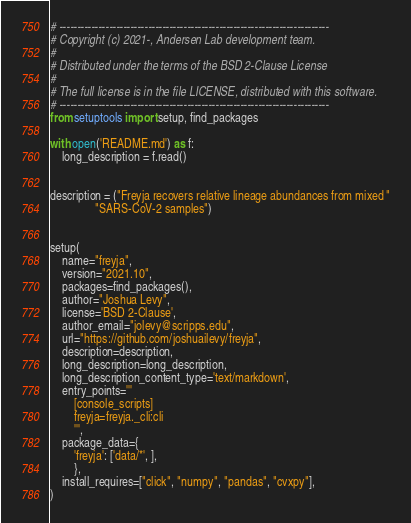Convert code to text. <code><loc_0><loc_0><loc_500><loc_500><_Python_># ----------------------------------------------------------------------------
# Copyright (c) 2021-, Andersen Lab development team.
#
# Distributed under the terms of the BSD 2-Clause License
#
# The full license is in the file LICENSE, distributed with this software.
# ----------------------------------------------------------------------------
from setuptools import setup, find_packages

with open('README.md') as f:
    long_description = f.read()


description = ("Freyja recovers relative lineage abundances from mixed "
               "SARS-CoV-2 samples")


setup(
    name="freyja",
    version="2021.10",
    packages=find_packages(),
    author="Joshua Levy",
    license='BSD 2-Clause',
    author_email="jolevy@scripps.edu",
    url="https://github.com/joshuailevy/freyja",
    description=description,
    long_description=long_description,
    long_description_content_type='text/markdown',
    entry_points='''
        [console_scripts]
        freyja=freyja._cli:cli
        ''',
    package_data={
        'freyja': ['data/*', ],
        },
    install_requires=["click", "numpy", "pandas", "cvxpy"],
)
</code> 